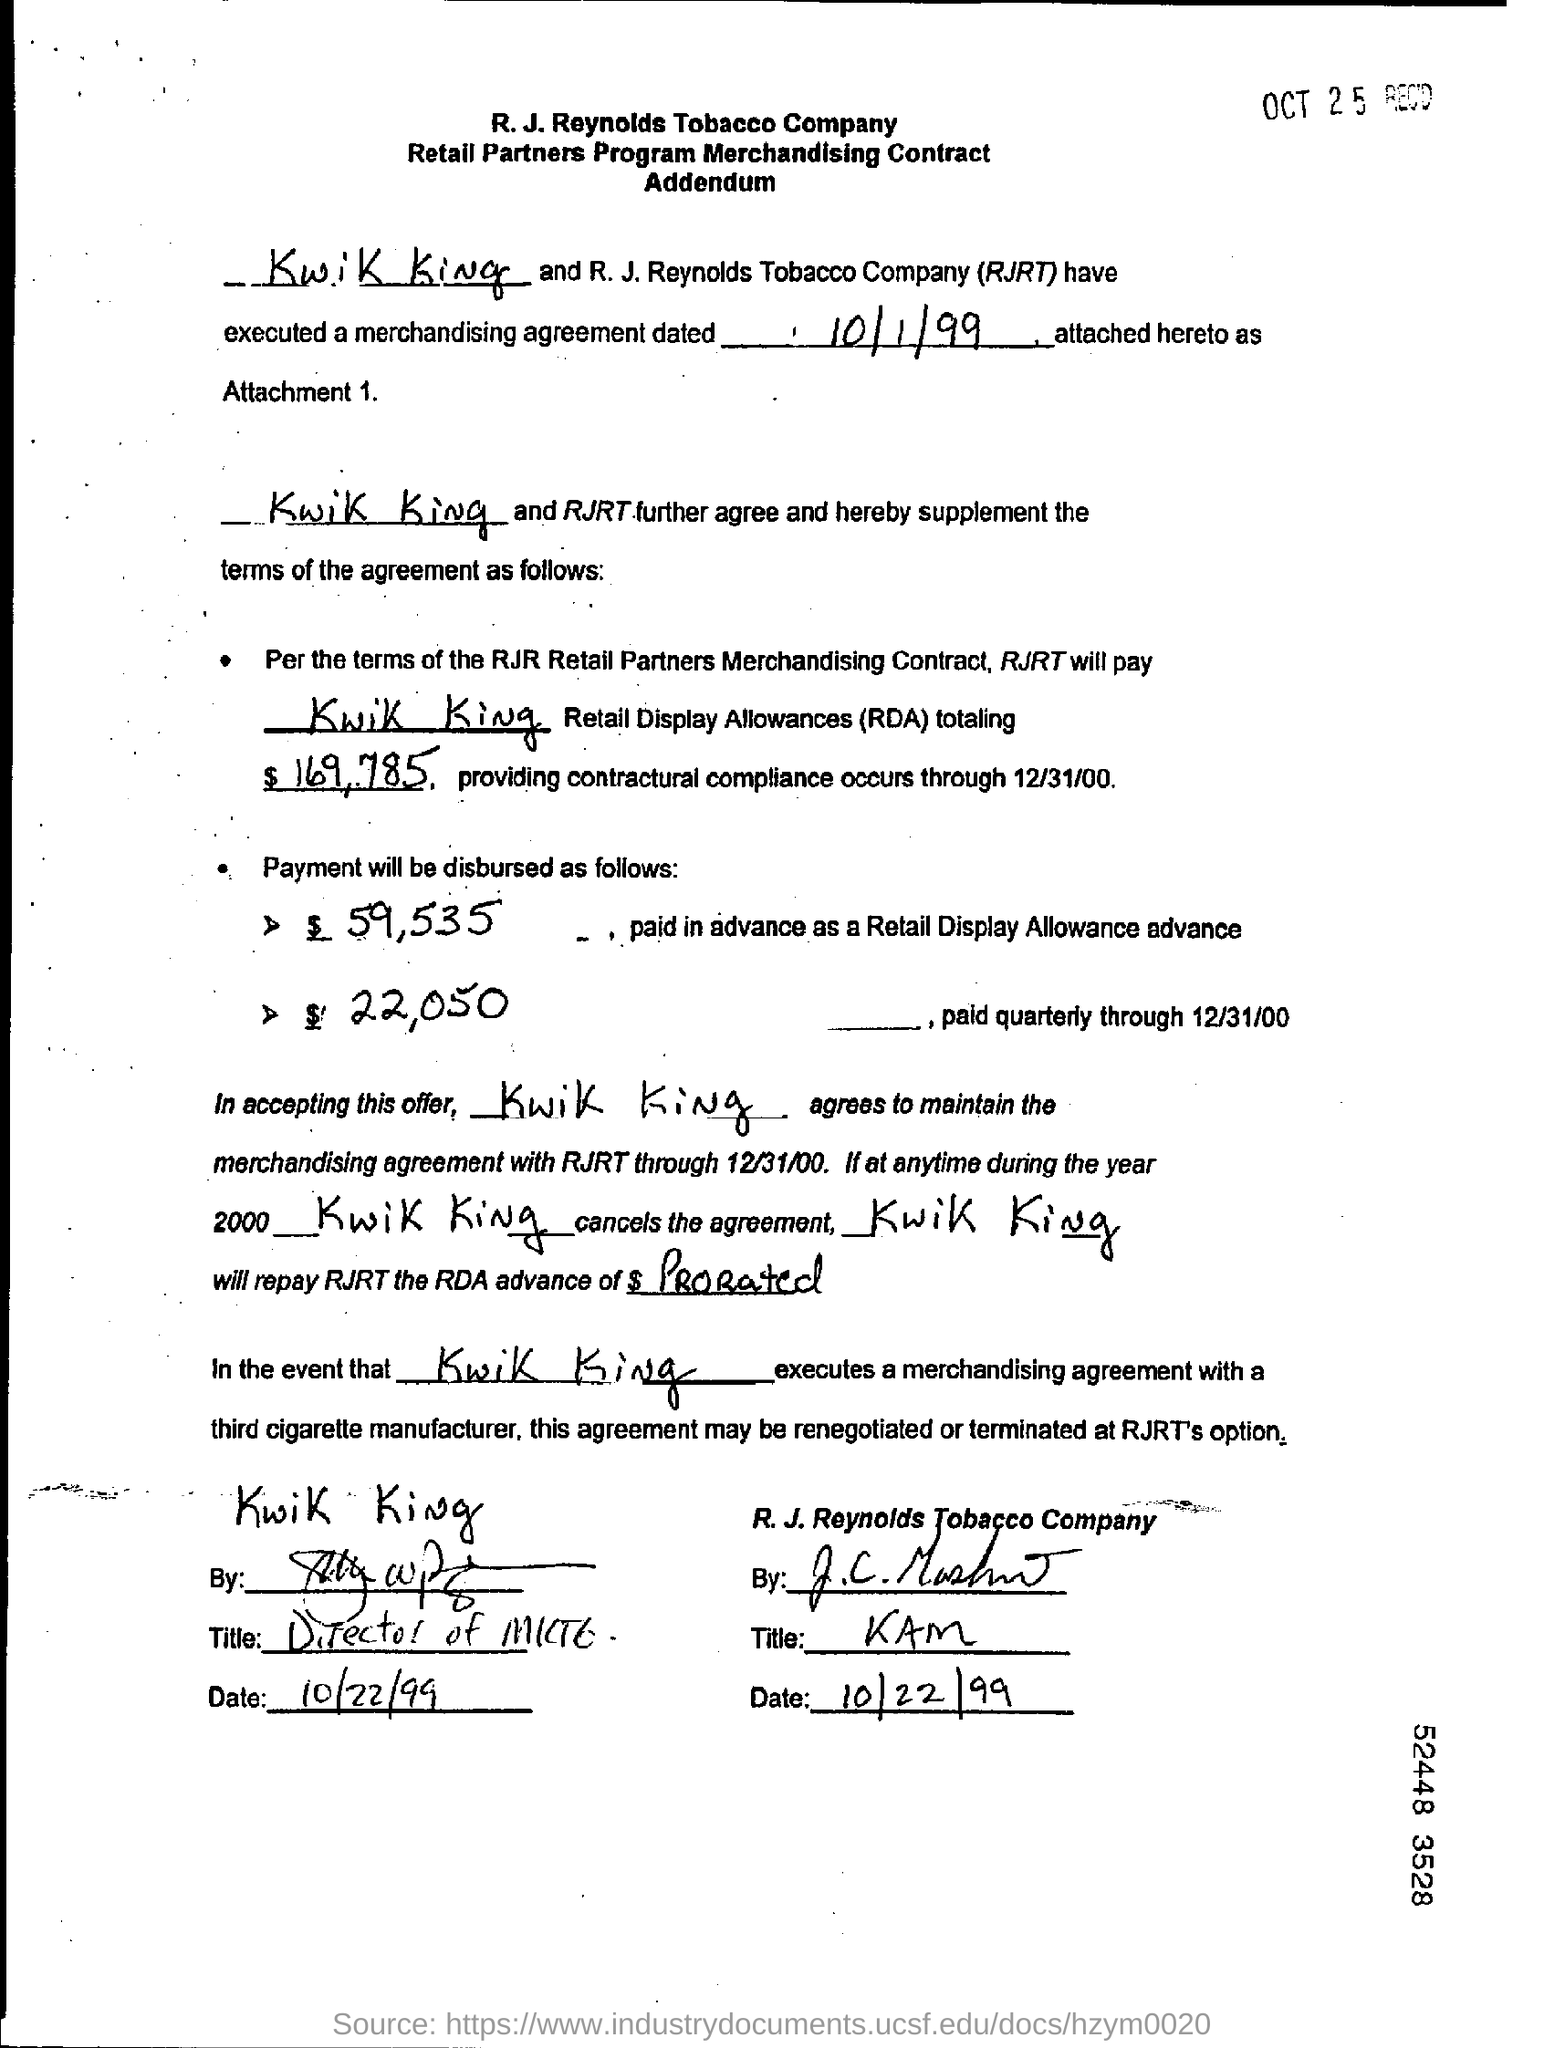When is the agreement dated?
Offer a very short reply. 10/1/99. Who will RJRT pay?
Offer a terse response. Kwik King. What is the total Retail Display Allowances?
Your answer should be compact. $169,785. What is the payment paid in advance as a Retail Display Allowance advance?
Give a very brief answer. $ 59,535. What is the payment paid quarterly through 12/31/00?
Provide a succinct answer. $22,050. When is it agreed to maintain the merchandisingagreement with RJRT through?
Make the answer very short. 12/31/00. 